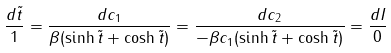Convert formula to latex. <formula><loc_0><loc_0><loc_500><loc_500>\frac { d \tilde { t } } { 1 } = \frac { d c _ { 1 } } { \beta ( \sinh \tilde { t } + \cosh \tilde { t } ) } = \frac { d c _ { 2 } } { - \beta c _ { 1 } ( \sinh \tilde { t } + \cosh \tilde { t } ) } = \frac { d I } { 0 }</formula> 